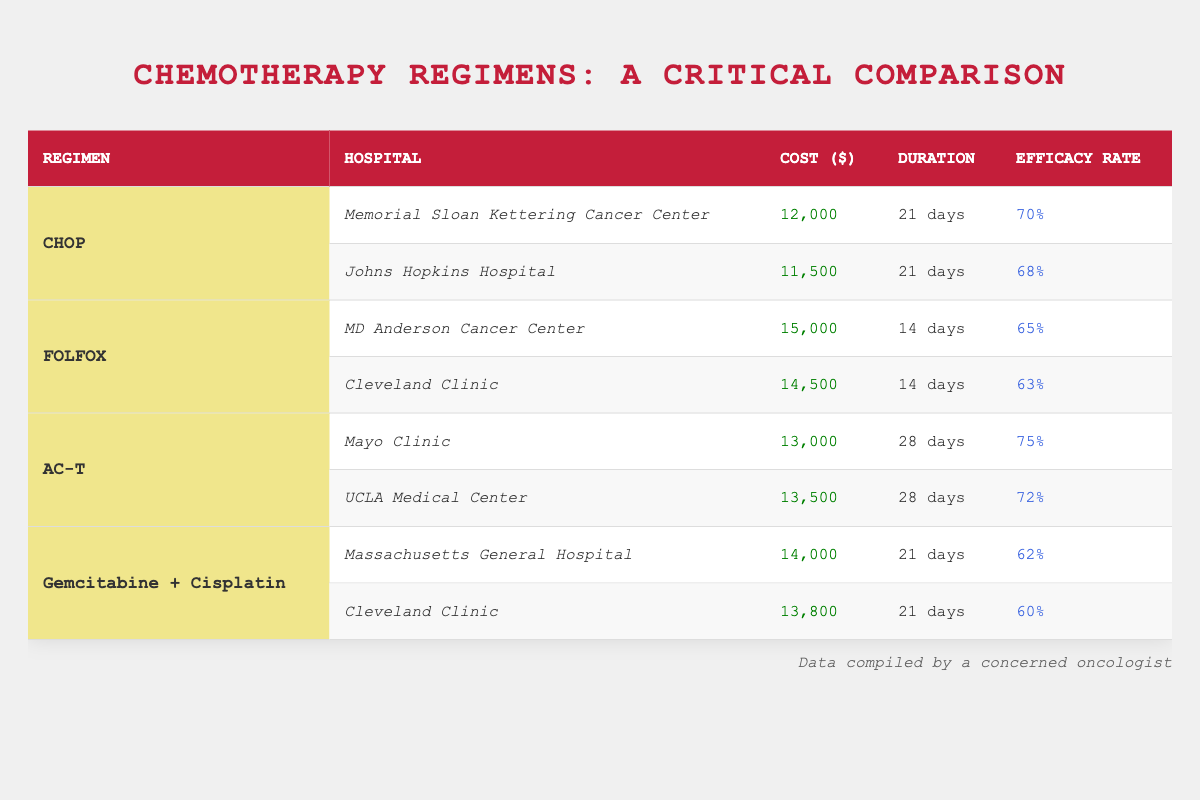What is the cost of the CHOP regimen at Memorial Sloan Kettering Cancer Center? The table lists the hospitals and corresponding regimens. For the CHOP regimen at Memorial Sloan Kettering Cancer Center, the cost is directly stated as 12000.
Answer: 12000 Which chemotherapy regimen has the highest efficacy rate shown in the table? By looking at the efficacy rates for each regimen, AC-T has a rate of 75%, which is higher than the rates of the other regimens listed.
Answer: AC-T What is the total cost of the FOLFOX regimen at both hospitals listed? The costs of the FOLFOX regimen at MD Anderson Cancer Center and Cleveland Clinic are 15000 and 14500, respectively. Adding these together gives 15000 + 14500 = 29500.
Answer: 29500 Does the UCLA Medical Center offer a chemotherapy regimen with a higher efficacy rate than 70%? The efficacy rate for the AC-T regimen at UCLA Medical Center is 72%, which is indeed higher than 70%. Thus, this statement is true.
Answer: Yes What is the average duration of the chemotherapy regimens listed in the table? The durations for the regimens are 21 days (CHOP), 14 days (FOLFOX), 28 days (AC-T), and 21 days (Gemcitabine + Cisplatin). Calculating the average: (21 + 14 + 28 + 21) / 4 = 21. The average duration is 21 days.
Answer: 21 days Which hospital has the lowest cost for a chemotherapy regimen? By comparing the costs among all hospitals listed in the table, Johns Hopkins Hospital has the lowest cost for the CHOP regimen at 11500, which is lower than the costs at the other hospitals.
Answer: Johns Hopkins Hospital How much more does the regimen at MD Anderson Cancer Center cost compared to the Cleveland Clinic for FOLFOX? The cost at MD Anderson Cancer Center is 15000, while at Cleveland Clinic it is 14500. The difference is 15000 - 14500 = 500.
Answer: 500 Is the efficacy rate of the Gemcitabine + Cisplatin regimen at Massachusetts General Hospital above 60%? The efficacy rate for the Gemcitabine + Cisplatin regimen at Massachusetts General Hospital is 62%, which is above 60%. Thus, this statement is true.
Answer: Yes What is the cost difference between the CHOP regimen and the FOLFOX regimen at the same hospital (Cleveland Clinic)? The cost for FOLFOX at Cleveland Clinic is 14500 and for CHOP it is 13800. The difference is 14500 - 13800 = 700.
Answer: 700 